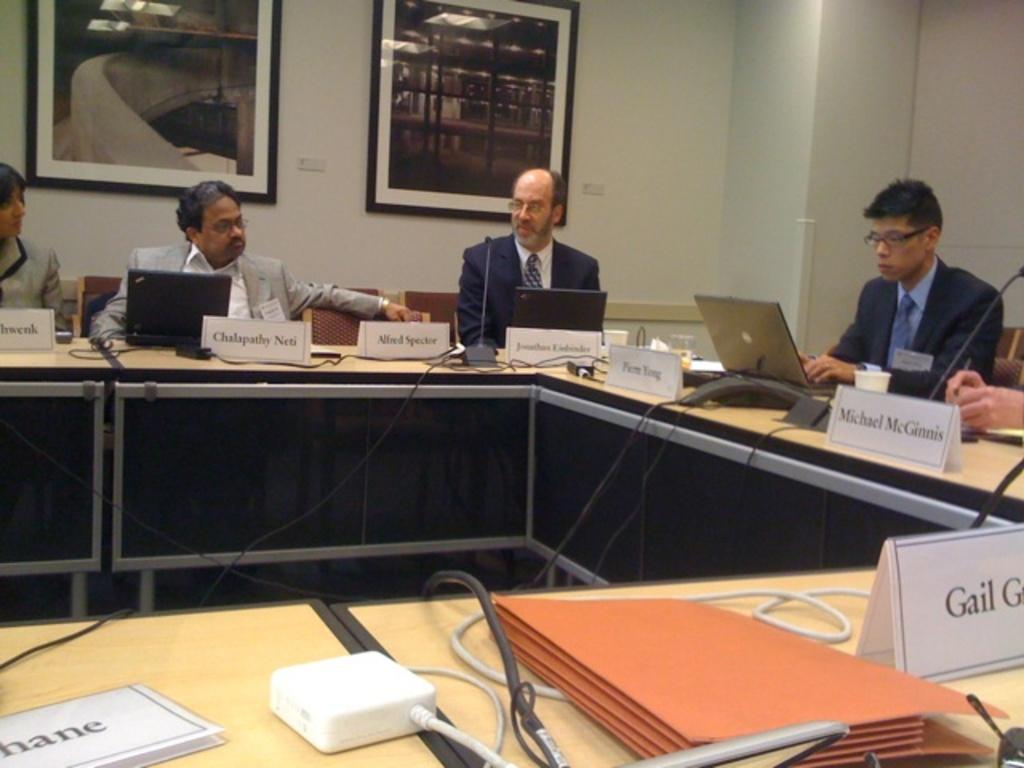What name is shown starting with the letter g?
Make the answer very short. Gail. What is the first name of mr. mcginnis?
Offer a very short reply. Michael. 